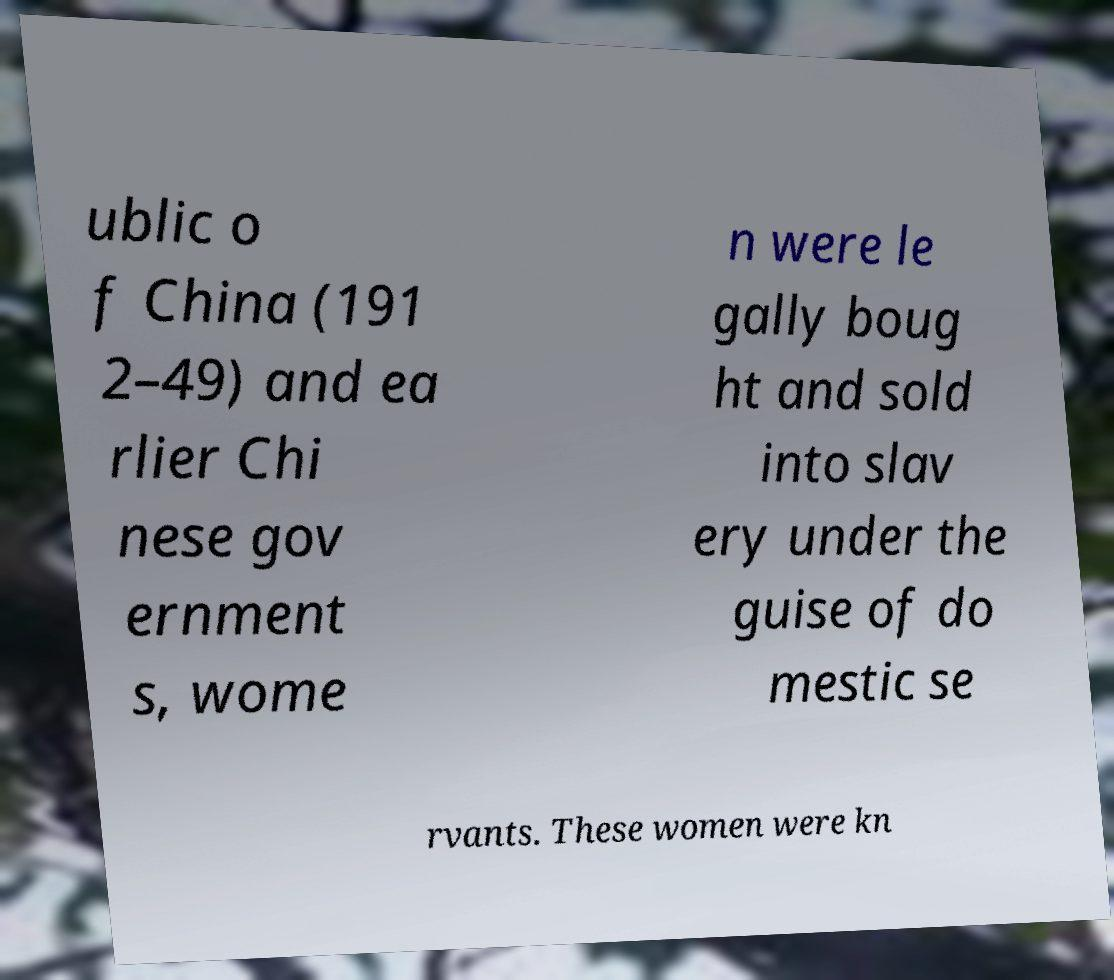Could you extract and type out the text from this image? ublic o f China (191 2–49) and ea rlier Chi nese gov ernment s, wome n were le gally boug ht and sold into slav ery under the guise of do mestic se rvants. These women were kn 